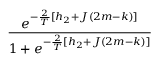Convert formula to latex. <formula><loc_0><loc_0><loc_500><loc_500>\frac { e ^ { - \frac { 2 } { T } [ h _ { 2 } + J ( 2 m - k ) ] } } { 1 + e ^ { - \frac { 2 } { T } [ h _ { 2 } + J ( 2 m - k ) ] } }</formula> 